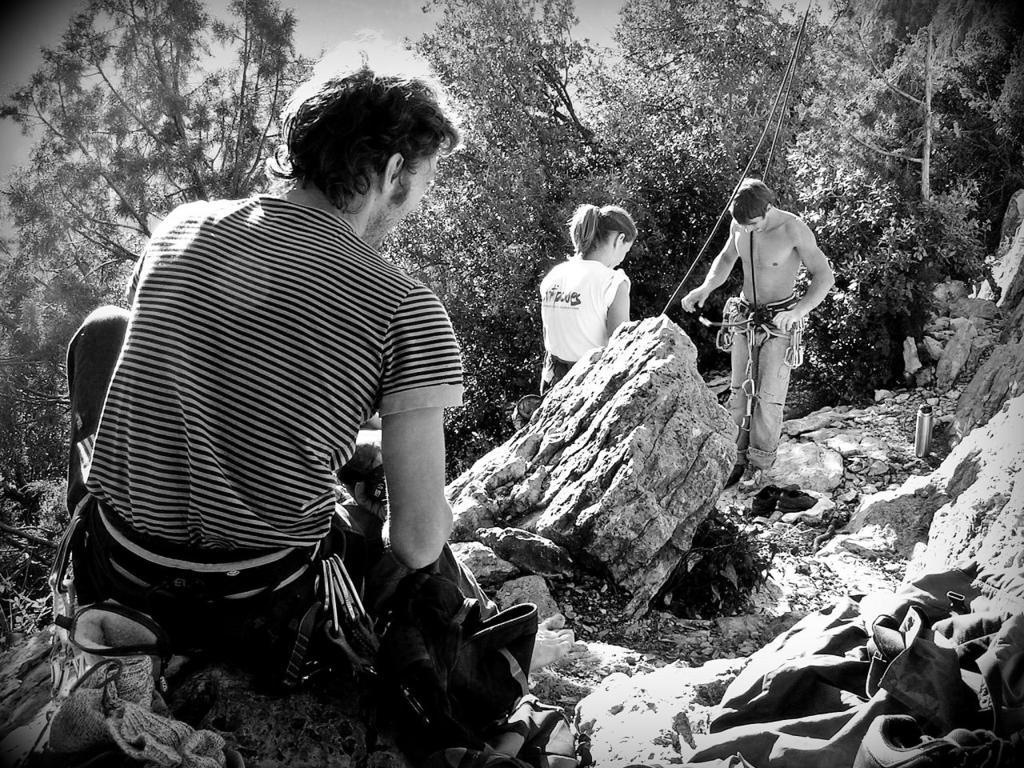What is the color scheme of the image? The image is black and white. What is the man in the image doing? The man is sitting on a rock in the image. How many people are present in the image? There are two people in the image, a woman and a man. What can be seen in the background of the image? There are trees in the background of the image. What type of adjustment is the woman making to the bear in the image? There are no bears present in the image, so no adjustments can be made to them. 